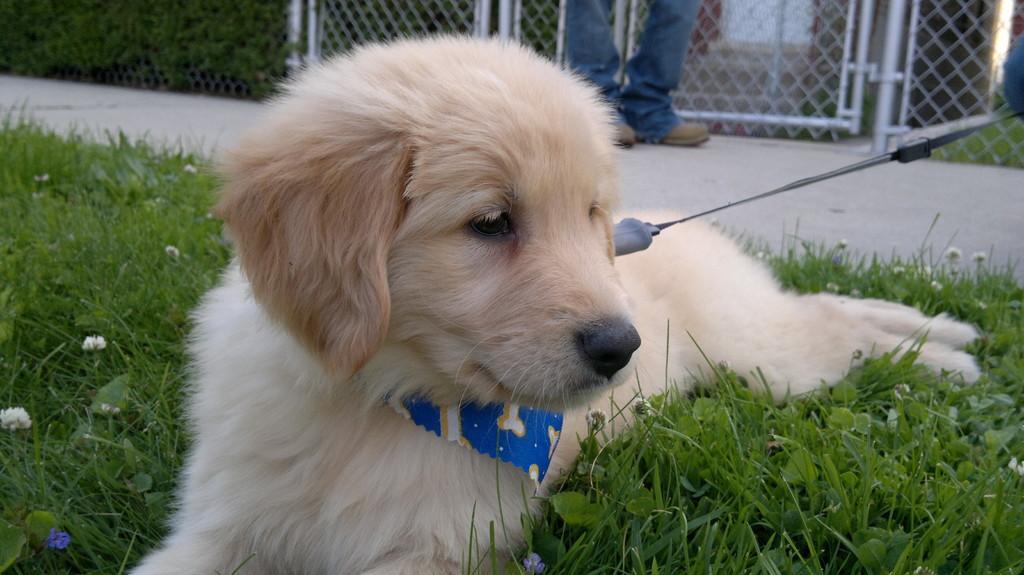In one or two sentences, can you explain what this image depicts? In the picture I can see a dog is sitting on the ground. The dog is wearing a neck belt. In the background I can see a person is standing. I can also see fence, the grass and some other objects. 